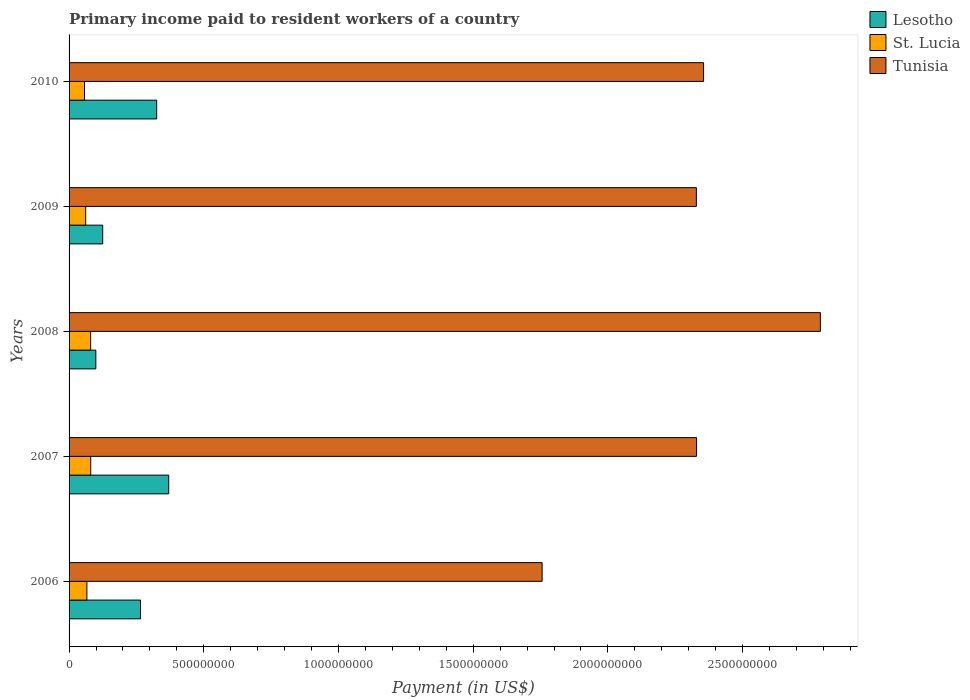How many bars are there on the 4th tick from the bottom?
Provide a succinct answer. 3. What is the label of the 4th group of bars from the top?
Ensure brevity in your answer.  2007. What is the amount paid to workers in Tunisia in 2009?
Give a very brief answer. 2.33e+09. Across all years, what is the maximum amount paid to workers in Lesotho?
Ensure brevity in your answer.  3.70e+08. Across all years, what is the minimum amount paid to workers in Tunisia?
Ensure brevity in your answer.  1.76e+09. In which year was the amount paid to workers in Lesotho maximum?
Offer a very short reply. 2007. In which year was the amount paid to workers in Tunisia minimum?
Provide a succinct answer. 2006. What is the total amount paid to workers in St. Lucia in the graph?
Make the answer very short. 3.46e+08. What is the difference between the amount paid to workers in Tunisia in 2006 and that in 2010?
Provide a succinct answer. -5.99e+08. What is the difference between the amount paid to workers in Tunisia in 2009 and the amount paid to workers in Lesotho in 2008?
Ensure brevity in your answer.  2.23e+09. What is the average amount paid to workers in St. Lucia per year?
Provide a succinct answer. 6.91e+07. In the year 2010, what is the difference between the amount paid to workers in Tunisia and amount paid to workers in St. Lucia?
Keep it short and to the point. 2.30e+09. What is the ratio of the amount paid to workers in Tunisia in 2009 to that in 2010?
Keep it short and to the point. 0.99. Is the amount paid to workers in Tunisia in 2007 less than that in 2008?
Your answer should be very brief. Yes. What is the difference between the highest and the second highest amount paid to workers in Lesotho?
Offer a terse response. 4.47e+07. What is the difference between the highest and the lowest amount paid to workers in St. Lucia?
Provide a short and direct response. 2.31e+07. Is the sum of the amount paid to workers in Lesotho in 2009 and 2010 greater than the maximum amount paid to workers in St. Lucia across all years?
Provide a short and direct response. Yes. What does the 1st bar from the top in 2008 represents?
Make the answer very short. Tunisia. What does the 1st bar from the bottom in 2009 represents?
Your answer should be very brief. Lesotho. Is it the case that in every year, the sum of the amount paid to workers in Lesotho and amount paid to workers in Tunisia is greater than the amount paid to workers in St. Lucia?
Your answer should be compact. Yes. Are all the bars in the graph horizontal?
Your response must be concise. Yes. How many years are there in the graph?
Provide a short and direct response. 5. Are the values on the major ticks of X-axis written in scientific E-notation?
Your response must be concise. No. What is the title of the graph?
Provide a succinct answer. Primary income paid to resident workers of a country. Does "Estonia" appear as one of the legend labels in the graph?
Provide a succinct answer. No. What is the label or title of the X-axis?
Offer a very short reply. Payment (in US$). What is the Payment (in US$) in Lesotho in 2006?
Offer a terse response. 2.65e+08. What is the Payment (in US$) in St. Lucia in 2006?
Your answer should be compact. 6.61e+07. What is the Payment (in US$) in Tunisia in 2006?
Your answer should be compact. 1.76e+09. What is the Payment (in US$) of Lesotho in 2007?
Offer a very short reply. 3.70e+08. What is the Payment (in US$) in St. Lucia in 2007?
Give a very brief answer. 8.04e+07. What is the Payment (in US$) of Tunisia in 2007?
Offer a terse response. 2.33e+09. What is the Payment (in US$) of Lesotho in 2008?
Keep it short and to the point. 9.93e+07. What is the Payment (in US$) in St. Lucia in 2008?
Provide a succinct answer. 8.01e+07. What is the Payment (in US$) of Tunisia in 2008?
Your answer should be very brief. 2.79e+09. What is the Payment (in US$) of Lesotho in 2009?
Give a very brief answer. 1.25e+08. What is the Payment (in US$) in St. Lucia in 2009?
Ensure brevity in your answer.  6.17e+07. What is the Payment (in US$) of Tunisia in 2009?
Offer a very short reply. 2.33e+09. What is the Payment (in US$) in Lesotho in 2010?
Make the answer very short. 3.25e+08. What is the Payment (in US$) in St. Lucia in 2010?
Your response must be concise. 5.73e+07. What is the Payment (in US$) of Tunisia in 2010?
Ensure brevity in your answer.  2.36e+09. Across all years, what is the maximum Payment (in US$) in Lesotho?
Your answer should be compact. 3.70e+08. Across all years, what is the maximum Payment (in US$) of St. Lucia?
Ensure brevity in your answer.  8.04e+07. Across all years, what is the maximum Payment (in US$) in Tunisia?
Offer a terse response. 2.79e+09. Across all years, what is the minimum Payment (in US$) of Lesotho?
Your answer should be compact. 9.93e+07. Across all years, what is the minimum Payment (in US$) in St. Lucia?
Make the answer very short. 5.73e+07. Across all years, what is the minimum Payment (in US$) of Tunisia?
Your answer should be very brief. 1.76e+09. What is the total Payment (in US$) of Lesotho in the graph?
Your response must be concise. 1.18e+09. What is the total Payment (in US$) of St. Lucia in the graph?
Offer a very short reply. 3.46e+08. What is the total Payment (in US$) of Tunisia in the graph?
Provide a short and direct response. 1.16e+1. What is the difference between the Payment (in US$) of Lesotho in 2006 and that in 2007?
Keep it short and to the point. -1.05e+08. What is the difference between the Payment (in US$) in St. Lucia in 2006 and that in 2007?
Provide a succinct answer. -1.43e+07. What is the difference between the Payment (in US$) in Tunisia in 2006 and that in 2007?
Offer a terse response. -5.73e+08. What is the difference between the Payment (in US$) in Lesotho in 2006 and that in 2008?
Provide a short and direct response. 1.66e+08. What is the difference between the Payment (in US$) of St. Lucia in 2006 and that in 2008?
Your response must be concise. -1.40e+07. What is the difference between the Payment (in US$) of Tunisia in 2006 and that in 2008?
Give a very brief answer. -1.03e+09. What is the difference between the Payment (in US$) in Lesotho in 2006 and that in 2009?
Your answer should be compact. 1.40e+08. What is the difference between the Payment (in US$) in St. Lucia in 2006 and that in 2009?
Your response must be concise. 4.46e+06. What is the difference between the Payment (in US$) in Tunisia in 2006 and that in 2009?
Your answer should be very brief. -5.72e+08. What is the difference between the Payment (in US$) of Lesotho in 2006 and that in 2010?
Provide a short and direct response. -5.99e+07. What is the difference between the Payment (in US$) of St. Lucia in 2006 and that in 2010?
Offer a very short reply. 8.85e+06. What is the difference between the Payment (in US$) of Tunisia in 2006 and that in 2010?
Make the answer very short. -5.99e+08. What is the difference between the Payment (in US$) of Lesotho in 2007 and that in 2008?
Ensure brevity in your answer.  2.70e+08. What is the difference between the Payment (in US$) in St. Lucia in 2007 and that in 2008?
Your answer should be very brief. 2.84e+05. What is the difference between the Payment (in US$) in Tunisia in 2007 and that in 2008?
Give a very brief answer. -4.59e+08. What is the difference between the Payment (in US$) in Lesotho in 2007 and that in 2009?
Your answer should be compact. 2.45e+08. What is the difference between the Payment (in US$) of St. Lucia in 2007 and that in 2009?
Provide a succinct answer. 1.87e+07. What is the difference between the Payment (in US$) of Tunisia in 2007 and that in 2009?
Offer a terse response. 8.24e+05. What is the difference between the Payment (in US$) of Lesotho in 2007 and that in 2010?
Ensure brevity in your answer.  4.47e+07. What is the difference between the Payment (in US$) in St. Lucia in 2007 and that in 2010?
Give a very brief answer. 2.31e+07. What is the difference between the Payment (in US$) of Tunisia in 2007 and that in 2010?
Ensure brevity in your answer.  -2.59e+07. What is the difference between the Payment (in US$) of Lesotho in 2008 and that in 2009?
Your response must be concise. -2.55e+07. What is the difference between the Payment (in US$) of St. Lucia in 2008 and that in 2009?
Ensure brevity in your answer.  1.84e+07. What is the difference between the Payment (in US$) in Tunisia in 2008 and that in 2009?
Your answer should be compact. 4.60e+08. What is the difference between the Payment (in US$) in Lesotho in 2008 and that in 2010?
Your response must be concise. -2.26e+08. What is the difference between the Payment (in US$) in St. Lucia in 2008 and that in 2010?
Give a very brief answer. 2.28e+07. What is the difference between the Payment (in US$) in Tunisia in 2008 and that in 2010?
Offer a very short reply. 4.34e+08. What is the difference between the Payment (in US$) in Lesotho in 2009 and that in 2010?
Ensure brevity in your answer.  -2.00e+08. What is the difference between the Payment (in US$) in St. Lucia in 2009 and that in 2010?
Keep it short and to the point. 4.39e+06. What is the difference between the Payment (in US$) in Tunisia in 2009 and that in 2010?
Your response must be concise. -2.68e+07. What is the difference between the Payment (in US$) in Lesotho in 2006 and the Payment (in US$) in St. Lucia in 2007?
Provide a succinct answer. 1.85e+08. What is the difference between the Payment (in US$) of Lesotho in 2006 and the Payment (in US$) of Tunisia in 2007?
Keep it short and to the point. -2.06e+09. What is the difference between the Payment (in US$) of St. Lucia in 2006 and the Payment (in US$) of Tunisia in 2007?
Keep it short and to the point. -2.26e+09. What is the difference between the Payment (in US$) in Lesotho in 2006 and the Payment (in US$) in St. Lucia in 2008?
Your answer should be compact. 1.85e+08. What is the difference between the Payment (in US$) in Lesotho in 2006 and the Payment (in US$) in Tunisia in 2008?
Your answer should be very brief. -2.52e+09. What is the difference between the Payment (in US$) of St. Lucia in 2006 and the Payment (in US$) of Tunisia in 2008?
Ensure brevity in your answer.  -2.72e+09. What is the difference between the Payment (in US$) in Lesotho in 2006 and the Payment (in US$) in St. Lucia in 2009?
Provide a short and direct response. 2.04e+08. What is the difference between the Payment (in US$) of Lesotho in 2006 and the Payment (in US$) of Tunisia in 2009?
Ensure brevity in your answer.  -2.06e+09. What is the difference between the Payment (in US$) of St. Lucia in 2006 and the Payment (in US$) of Tunisia in 2009?
Your answer should be compact. -2.26e+09. What is the difference between the Payment (in US$) in Lesotho in 2006 and the Payment (in US$) in St. Lucia in 2010?
Provide a succinct answer. 2.08e+08. What is the difference between the Payment (in US$) of Lesotho in 2006 and the Payment (in US$) of Tunisia in 2010?
Give a very brief answer. -2.09e+09. What is the difference between the Payment (in US$) of St. Lucia in 2006 and the Payment (in US$) of Tunisia in 2010?
Offer a very short reply. -2.29e+09. What is the difference between the Payment (in US$) in Lesotho in 2007 and the Payment (in US$) in St. Lucia in 2008?
Make the answer very short. 2.90e+08. What is the difference between the Payment (in US$) in Lesotho in 2007 and the Payment (in US$) in Tunisia in 2008?
Offer a very short reply. -2.42e+09. What is the difference between the Payment (in US$) of St. Lucia in 2007 and the Payment (in US$) of Tunisia in 2008?
Offer a very short reply. -2.71e+09. What is the difference between the Payment (in US$) of Lesotho in 2007 and the Payment (in US$) of St. Lucia in 2009?
Offer a very short reply. 3.08e+08. What is the difference between the Payment (in US$) of Lesotho in 2007 and the Payment (in US$) of Tunisia in 2009?
Provide a succinct answer. -1.96e+09. What is the difference between the Payment (in US$) in St. Lucia in 2007 and the Payment (in US$) in Tunisia in 2009?
Ensure brevity in your answer.  -2.25e+09. What is the difference between the Payment (in US$) of Lesotho in 2007 and the Payment (in US$) of St. Lucia in 2010?
Make the answer very short. 3.13e+08. What is the difference between the Payment (in US$) of Lesotho in 2007 and the Payment (in US$) of Tunisia in 2010?
Offer a very short reply. -1.99e+09. What is the difference between the Payment (in US$) in St. Lucia in 2007 and the Payment (in US$) in Tunisia in 2010?
Give a very brief answer. -2.27e+09. What is the difference between the Payment (in US$) of Lesotho in 2008 and the Payment (in US$) of St. Lucia in 2009?
Offer a very short reply. 3.77e+07. What is the difference between the Payment (in US$) in Lesotho in 2008 and the Payment (in US$) in Tunisia in 2009?
Keep it short and to the point. -2.23e+09. What is the difference between the Payment (in US$) in St. Lucia in 2008 and the Payment (in US$) in Tunisia in 2009?
Ensure brevity in your answer.  -2.25e+09. What is the difference between the Payment (in US$) in Lesotho in 2008 and the Payment (in US$) in St. Lucia in 2010?
Make the answer very short. 4.21e+07. What is the difference between the Payment (in US$) of Lesotho in 2008 and the Payment (in US$) of Tunisia in 2010?
Keep it short and to the point. -2.26e+09. What is the difference between the Payment (in US$) in St. Lucia in 2008 and the Payment (in US$) in Tunisia in 2010?
Provide a succinct answer. -2.27e+09. What is the difference between the Payment (in US$) in Lesotho in 2009 and the Payment (in US$) in St. Lucia in 2010?
Provide a short and direct response. 6.75e+07. What is the difference between the Payment (in US$) of Lesotho in 2009 and the Payment (in US$) of Tunisia in 2010?
Make the answer very short. -2.23e+09. What is the difference between the Payment (in US$) of St. Lucia in 2009 and the Payment (in US$) of Tunisia in 2010?
Your answer should be compact. -2.29e+09. What is the average Payment (in US$) of Lesotho per year?
Give a very brief answer. 2.37e+08. What is the average Payment (in US$) in St. Lucia per year?
Your answer should be very brief. 6.91e+07. What is the average Payment (in US$) of Tunisia per year?
Your answer should be very brief. 2.31e+09. In the year 2006, what is the difference between the Payment (in US$) in Lesotho and Payment (in US$) in St. Lucia?
Offer a very short reply. 1.99e+08. In the year 2006, what is the difference between the Payment (in US$) in Lesotho and Payment (in US$) in Tunisia?
Provide a succinct answer. -1.49e+09. In the year 2006, what is the difference between the Payment (in US$) of St. Lucia and Payment (in US$) of Tunisia?
Offer a very short reply. -1.69e+09. In the year 2007, what is the difference between the Payment (in US$) in Lesotho and Payment (in US$) in St. Lucia?
Provide a short and direct response. 2.89e+08. In the year 2007, what is the difference between the Payment (in US$) of Lesotho and Payment (in US$) of Tunisia?
Give a very brief answer. -1.96e+09. In the year 2007, what is the difference between the Payment (in US$) in St. Lucia and Payment (in US$) in Tunisia?
Your answer should be very brief. -2.25e+09. In the year 2008, what is the difference between the Payment (in US$) in Lesotho and Payment (in US$) in St. Lucia?
Offer a terse response. 1.92e+07. In the year 2008, what is the difference between the Payment (in US$) of Lesotho and Payment (in US$) of Tunisia?
Offer a very short reply. -2.69e+09. In the year 2008, what is the difference between the Payment (in US$) of St. Lucia and Payment (in US$) of Tunisia?
Ensure brevity in your answer.  -2.71e+09. In the year 2009, what is the difference between the Payment (in US$) of Lesotho and Payment (in US$) of St. Lucia?
Your answer should be compact. 6.31e+07. In the year 2009, what is the difference between the Payment (in US$) in Lesotho and Payment (in US$) in Tunisia?
Offer a terse response. -2.20e+09. In the year 2009, what is the difference between the Payment (in US$) of St. Lucia and Payment (in US$) of Tunisia?
Give a very brief answer. -2.27e+09. In the year 2010, what is the difference between the Payment (in US$) of Lesotho and Payment (in US$) of St. Lucia?
Give a very brief answer. 2.68e+08. In the year 2010, what is the difference between the Payment (in US$) of Lesotho and Payment (in US$) of Tunisia?
Make the answer very short. -2.03e+09. In the year 2010, what is the difference between the Payment (in US$) of St. Lucia and Payment (in US$) of Tunisia?
Keep it short and to the point. -2.30e+09. What is the ratio of the Payment (in US$) in Lesotho in 2006 to that in 2007?
Your response must be concise. 0.72. What is the ratio of the Payment (in US$) of St. Lucia in 2006 to that in 2007?
Provide a short and direct response. 0.82. What is the ratio of the Payment (in US$) in Tunisia in 2006 to that in 2007?
Your answer should be compact. 0.75. What is the ratio of the Payment (in US$) of Lesotho in 2006 to that in 2008?
Your response must be concise. 2.67. What is the ratio of the Payment (in US$) in St. Lucia in 2006 to that in 2008?
Give a very brief answer. 0.83. What is the ratio of the Payment (in US$) of Tunisia in 2006 to that in 2008?
Provide a short and direct response. 0.63. What is the ratio of the Payment (in US$) of Lesotho in 2006 to that in 2009?
Make the answer very short. 2.13. What is the ratio of the Payment (in US$) in St. Lucia in 2006 to that in 2009?
Give a very brief answer. 1.07. What is the ratio of the Payment (in US$) of Tunisia in 2006 to that in 2009?
Offer a terse response. 0.75. What is the ratio of the Payment (in US$) in Lesotho in 2006 to that in 2010?
Offer a terse response. 0.82. What is the ratio of the Payment (in US$) in St. Lucia in 2006 to that in 2010?
Your response must be concise. 1.15. What is the ratio of the Payment (in US$) in Tunisia in 2006 to that in 2010?
Ensure brevity in your answer.  0.75. What is the ratio of the Payment (in US$) of Lesotho in 2007 to that in 2008?
Ensure brevity in your answer.  3.72. What is the ratio of the Payment (in US$) in St. Lucia in 2007 to that in 2008?
Your response must be concise. 1. What is the ratio of the Payment (in US$) in Tunisia in 2007 to that in 2008?
Make the answer very short. 0.84. What is the ratio of the Payment (in US$) of Lesotho in 2007 to that in 2009?
Offer a terse response. 2.96. What is the ratio of the Payment (in US$) of St. Lucia in 2007 to that in 2009?
Your response must be concise. 1.3. What is the ratio of the Payment (in US$) in Lesotho in 2007 to that in 2010?
Make the answer very short. 1.14. What is the ratio of the Payment (in US$) in St. Lucia in 2007 to that in 2010?
Ensure brevity in your answer.  1.4. What is the ratio of the Payment (in US$) in Lesotho in 2008 to that in 2009?
Your response must be concise. 0.8. What is the ratio of the Payment (in US$) of St. Lucia in 2008 to that in 2009?
Make the answer very short. 1.3. What is the ratio of the Payment (in US$) in Tunisia in 2008 to that in 2009?
Your answer should be very brief. 1.2. What is the ratio of the Payment (in US$) of Lesotho in 2008 to that in 2010?
Provide a succinct answer. 0.31. What is the ratio of the Payment (in US$) of St. Lucia in 2008 to that in 2010?
Give a very brief answer. 1.4. What is the ratio of the Payment (in US$) in Tunisia in 2008 to that in 2010?
Provide a short and direct response. 1.18. What is the ratio of the Payment (in US$) in Lesotho in 2009 to that in 2010?
Your answer should be very brief. 0.38. What is the ratio of the Payment (in US$) in St. Lucia in 2009 to that in 2010?
Give a very brief answer. 1.08. What is the difference between the highest and the second highest Payment (in US$) in Lesotho?
Offer a very short reply. 4.47e+07. What is the difference between the highest and the second highest Payment (in US$) in St. Lucia?
Keep it short and to the point. 2.84e+05. What is the difference between the highest and the second highest Payment (in US$) of Tunisia?
Offer a very short reply. 4.34e+08. What is the difference between the highest and the lowest Payment (in US$) of Lesotho?
Offer a very short reply. 2.70e+08. What is the difference between the highest and the lowest Payment (in US$) of St. Lucia?
Make the answer very short. 2.31e+07. What is the difference between the highest and the lowest Payment (in US$) in Tunisia?
Ensure brevity in your answer.  1.03e+09. 